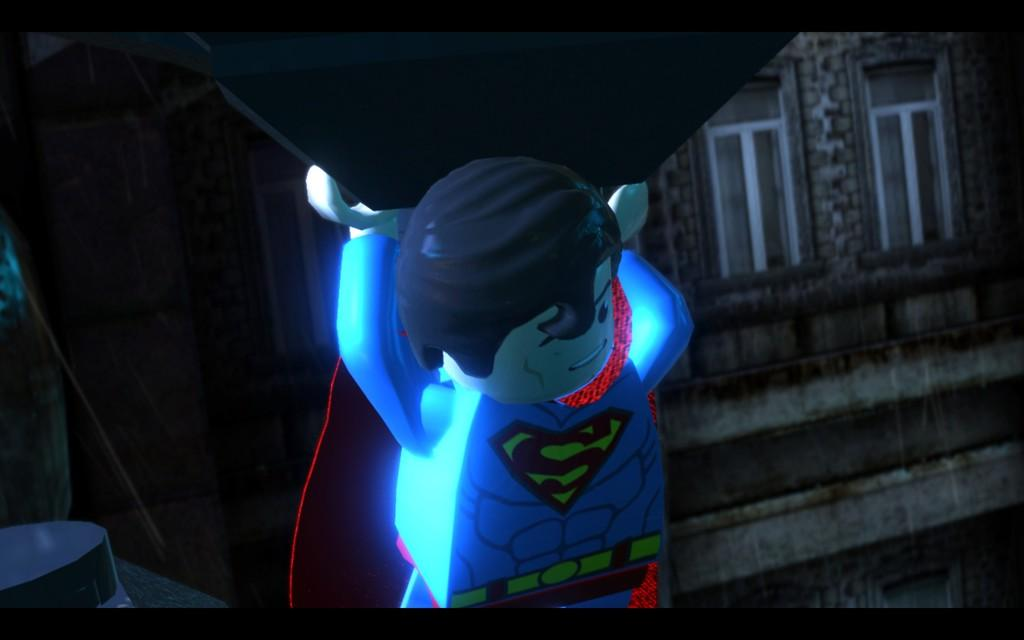What is the main subject in the foreground of the image? There is a person in the foreground of the image. What is the person doing in the image? The person is carrying something. What can be seen in the background of the image? There is a building in the background of the image. How many lizards can be seen on the door in the image? There is no door or lizards present in the image. 